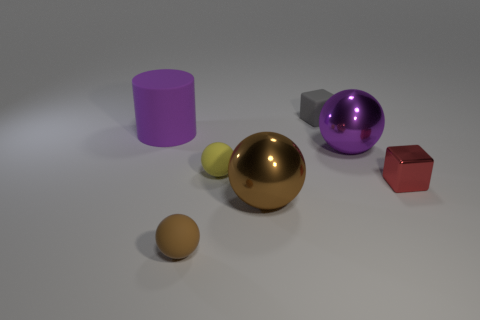There is a ball that is behind the small metal cube and in front of the big purple shiny thing; what is its size?
Your response must be concise. Small. Are there more big objects behind the red cube than big objects to the right of the big purple metallic thing?
Provide a short and direct response. Yes. There is a small red thing; is it the same shape as the tiny rubber object behind the large purple metal sphere?
Provide a succinct answer. Yes. How many other things are there of the same shape as the small gray thing?
Offer a terse response. 1. There is a object that is behind the tiny red shiny object and to the right of the rubber block; what is its color?
Your answer should be very brief. Purple. The metallic block has what color?
Make the answer very short. Red. Are the red block and the large object that is in front of the tiny red metal cube made of the same material?
Your answer should be compact. Yes. What shape is the purple thing that is the same material as the gray object?
Ensure brevity in your answer.  Cylinder. There is another rubber sphere that is the same size as the brown rubber ball; what color is it?
Keep it short and to the point. Yellow. There is a block behind the cylinder; is its size the same as the metallic block?
Ensure brevity in your answer.  Yes. 